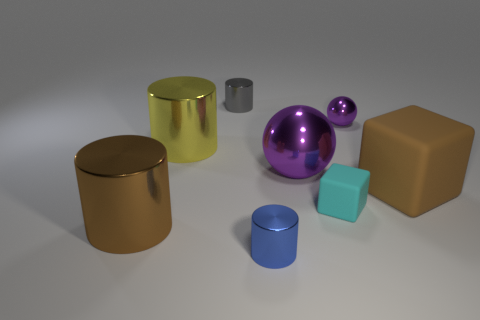There is another large thing that is the same color as the big rubber object; what is its shape?
Offer a terse response. Cylinder. Is there any other thing that has the same shape as the big purple shiny thing?
Offer a very short reply. Yes. What number of balls are either yellow shiny things or small objects?
Your response must be concise. 1. What color is the small cylinder that is in front of the gray shiny object?
Offer a very short reply. Blue. What shape is the purple shiny thing that is the same size as the yellow cylinder?
Make the answer very short. Sphere. What number of big things are in front of the blue metal thing?
Ensure brevity in your answer.  0. How many things are big yellow rubber balls or big brown blocks?
Your answer should be compact. 1. What is the shape of the large object that is on the left side of the small ball and right of the yellow cylinder?
Provide a short and direct response. Sphere. What number of blue shiny things are there?
Offer a very short reply. 1. There is a large ball that is the same material as the tiny gray object; what is its color?
Ensure brevity in your answer.  Purple. 